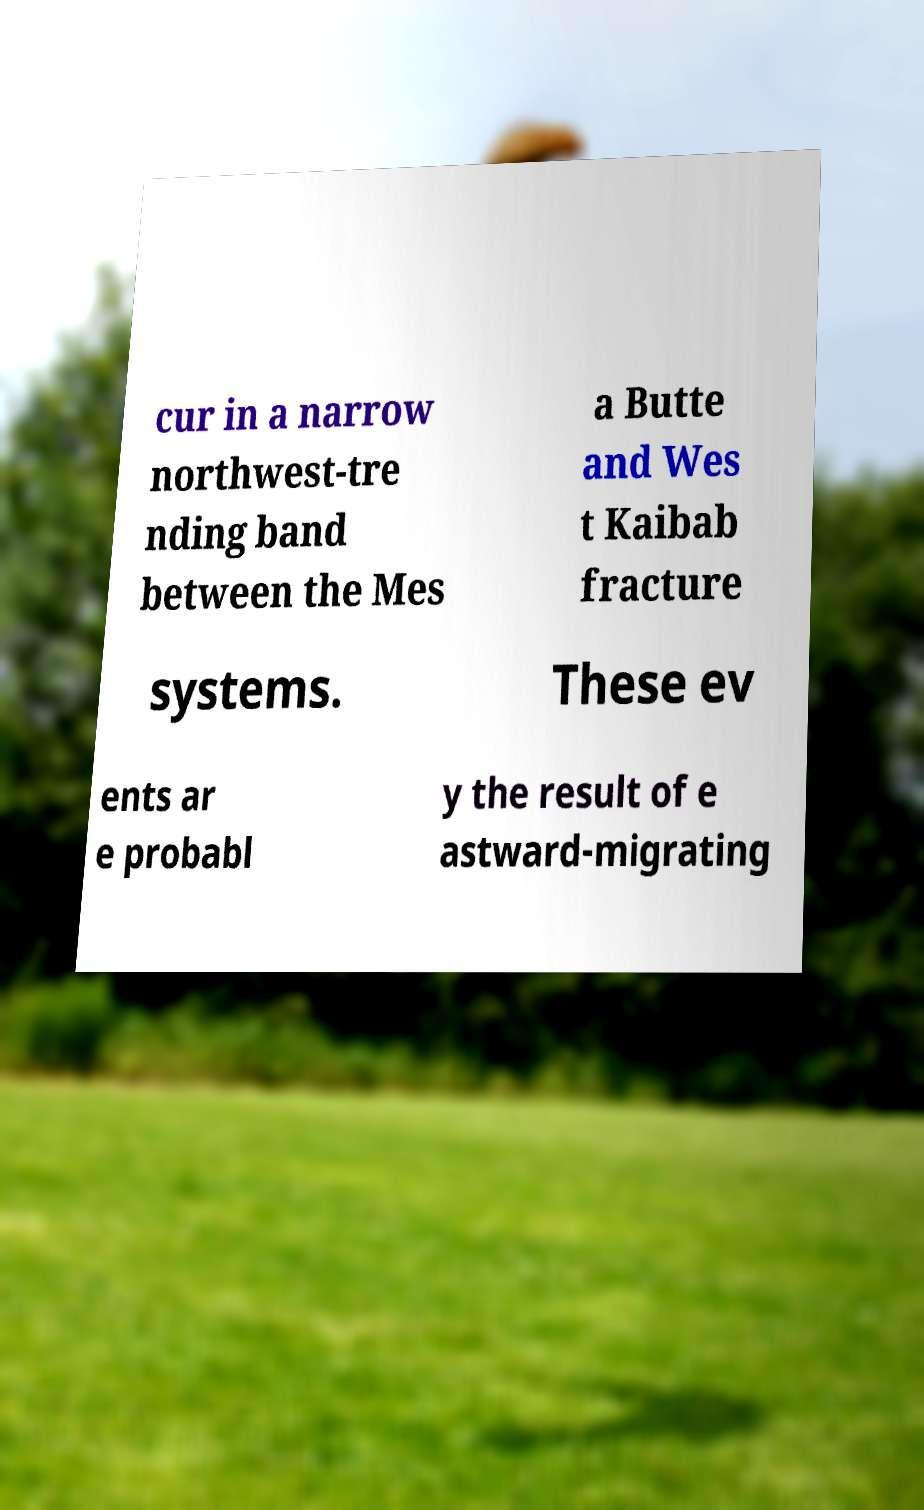There's text embedded in this image that I need extracted. Can you transcribe it verbatim? cur in a narrow northwest-tre nding band between the Mes a Butte and Wes t Kaibab fracture systems. These ev ents ar e probabl y the result of e astward-migrating 